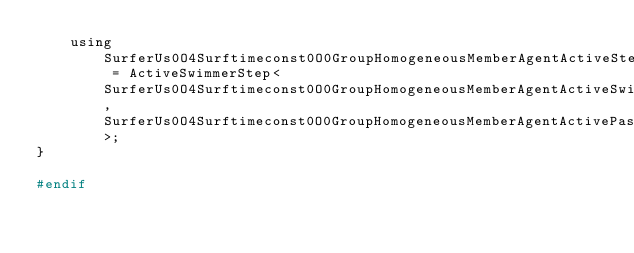Convert code to text. <code><loc_0><loc_0><loc_500><loc_500><_C_>    using SurferUs0O4Surftimeconst0O0GroupHomogeneousMemberAgentActiveStep = ActiveSwimmerStep<SurferUs0O4Surftimeconst0O0GroupHomogeneousMemberAgentActiveSwimmerStepParameters, SurferUs0O4Surftimeconst0O0GroupHomogeneousMemberAgentActivePassiveStep>;
}

#endif
</code> 